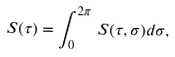Convert formula to latex. <formula><loc_0><loc_0><loc_500><loc_500>S ( \tau ) = \int _ { 0 } ^ { 2 \pi } \, S ( \tau , \sigma ) d \sigma ,</formula> 